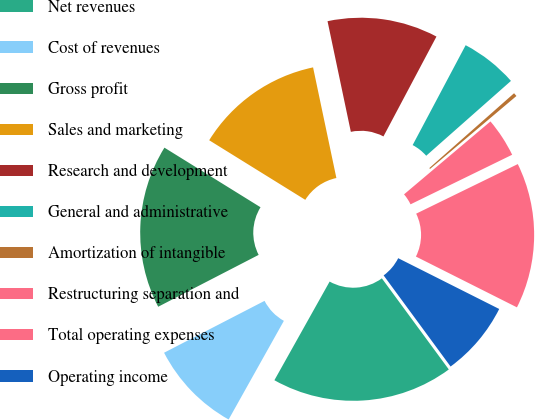<chart> <loc_0><loc_0><loc_500><loc_500><pie_chart><fcel>Net revenues<fcel>Cost of revenues<fcel>Gross profit<fcel>Sales and marketing<fcel>Research and development<fcel>General and administrative<fcel>Amortization of intangible<fcel>Restructuring separation and<fcel>Total operating expenses<fcel>Operating income<nl><fcel>18.21%<fcel>9.29%<fcel>16.42%<fcel>12.86%<fcel>11.07%<fcel>5.72%<fcel>0.36%<fcel>3.93%<fcel>14.64%<fcel>7.5%<nl></chart> 